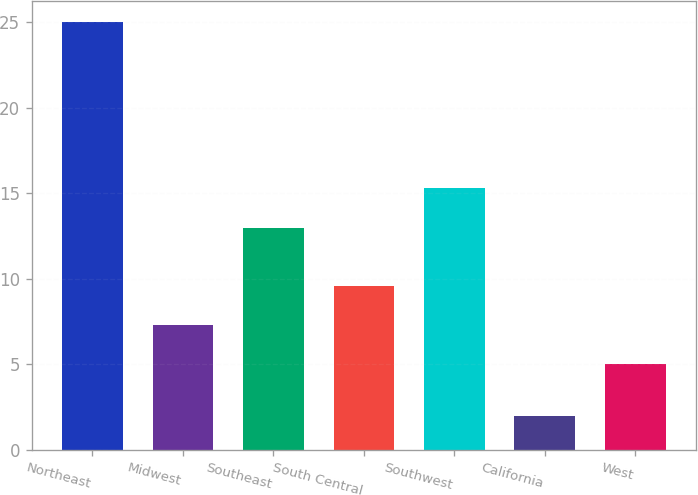Convert chart to OTSL. <chart><loc_0><loc_0><loc_500><loc_500><bar_chart><fcel>Northeast<fcel>Midwest<fcel>Southeast<fcel>South Central<fcel>Southwest<fcel>California<fcel>West<nl><fcel>25<fcel>7.3<fcel>13<fcel>9.6<fcel>15.3<fcel>2<fcel>5<nl></chart> 